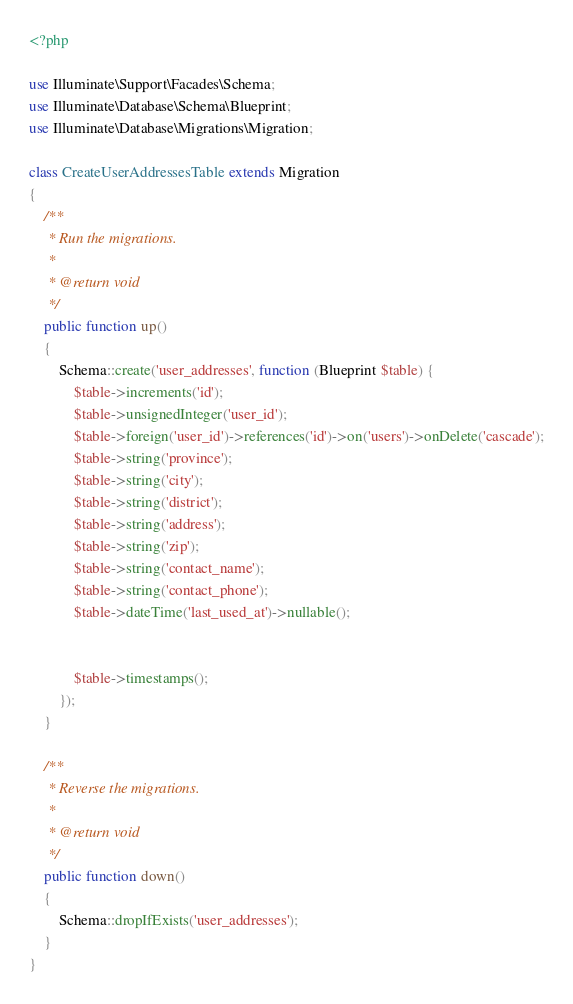<code> <loc_0><loc_0><loc_500><loc_500><_PHP_><?php

use Illuminate\Support\Facades\Schema;
use Illuminate\Database\Schema\Blueprint;
use Illuminate\Database\Migrations\Migration;

class CreateUserAddressesTable extends Migration
{
    /**
     * Run the migrations.
     *
     * @return void
     */
    public function up()
    {
        Schema::create('user_addresses', function (Blueprint $table) {
            $table->increments('id');
            $table->unsignedInteger('user_id');
            $table->foreign('user_id')->references('id')->on('users')->onDelete('cascade');
            $table->string('province');
            $table->string('city');
            $table->string('district');
            $table->string('address');
            $table->string('zip');
            $table->string('contact_name');
            $table->string('contact_phone');
            $table->dateTime('last_used_at')->nullable();


            $table->timestamps();
        });
    }

    /**
     * Reverse the migrations.
     *
     * @return void
     */
    public function down()
    {
        Schema::dropIfExists('user_addresses');
    }
}
</code> 